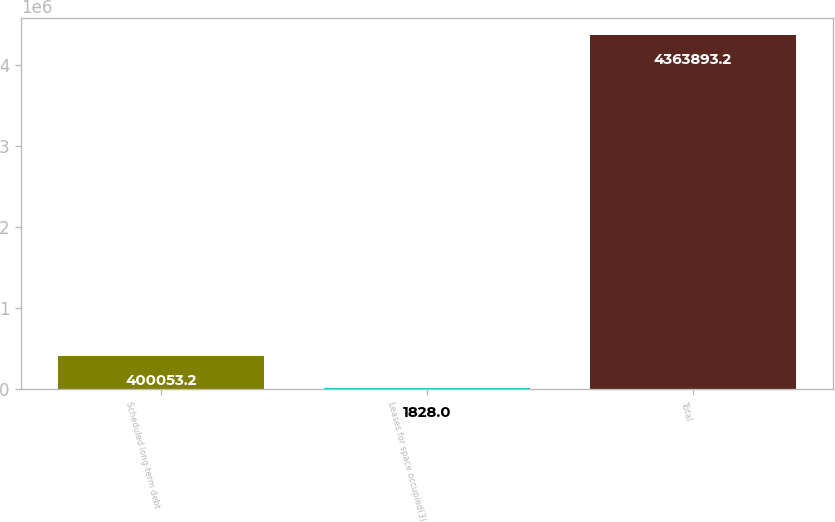Convert chart. <chart><loc_0><loc_0><loc_500><loc_500><bar_chart><fcel>Scheduled long-term debt<fcel>Leases for space occupied(3)<fcel>Total<nl><fcel>400053<fcel>1828<fcel>4.36389e+06<nl></chart> 